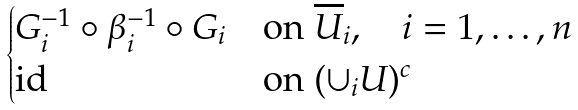<formula> <loc_0><loc_0><loc_500><loc_500>\begin{cases} G _ { i } ^ { - 1 } \circ \beta _ { i } ^ { - 1 } \circ G _ { i } & \text {on } \overline { U } _ { i } , \quad i = 1 , \dots , n \\ \text {id} & \text {on } ( \cup _ { i } U ) ^ { c } \end{cases}</formula> 